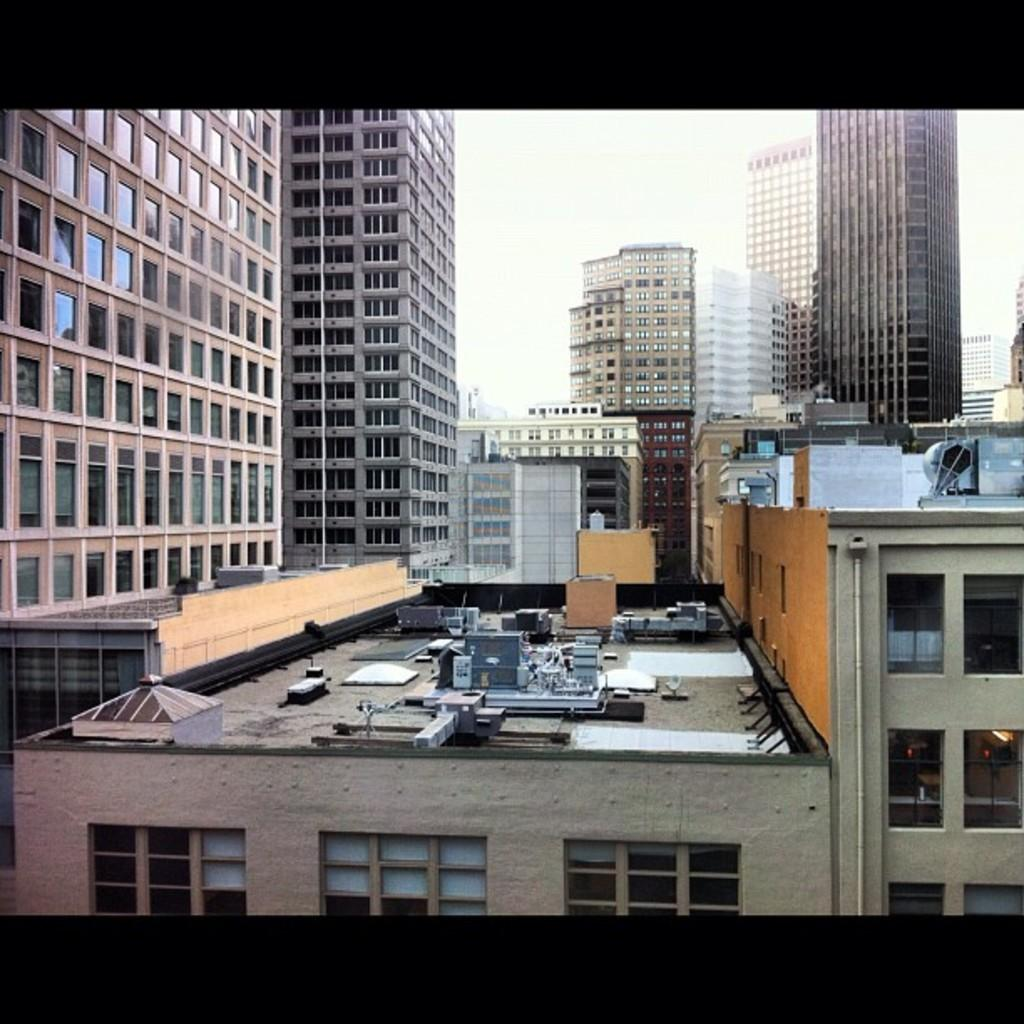What structures are located in the middle of the image? There are buildings in the middle of the image. What is visible at the top of the image? The sky is visible at the top of the image. How many potatoes are visible in the image? There are no potatoes present in the image. Are there any ghosts or chickens visible in the image? There are no ghosts or chickens present in the image. 